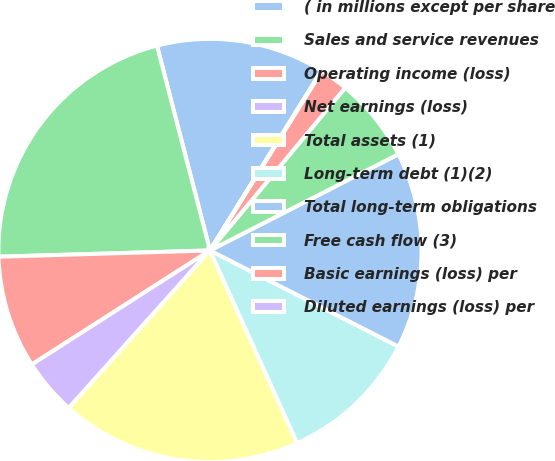Convert chart. <chart><loc_0><loc_0><loc_500><loc_500><pie_chart><fcel>( in millions except per share<fcel>Sales and service revenues<fcel>Operating income (loss)<fcel>Net earnings (loss)<fcel>Total assets (1)<fcel>Long-term debt (1)(2)<fcel>Total long-term obligations<fcel>Free cash flow (3)<fcel>Basic earnings (loss) per<fcel>Diluted earnings (loss) per<nl><fcel>12.87%<fcel>21.44%<fcel>8.59%<fcel>4.31%<fcel>18.4%<fcel>10.73%<fcel>15.02%<fcel>6.45%<fcel>2.17%<fcel>0.03%<nl></chart> 